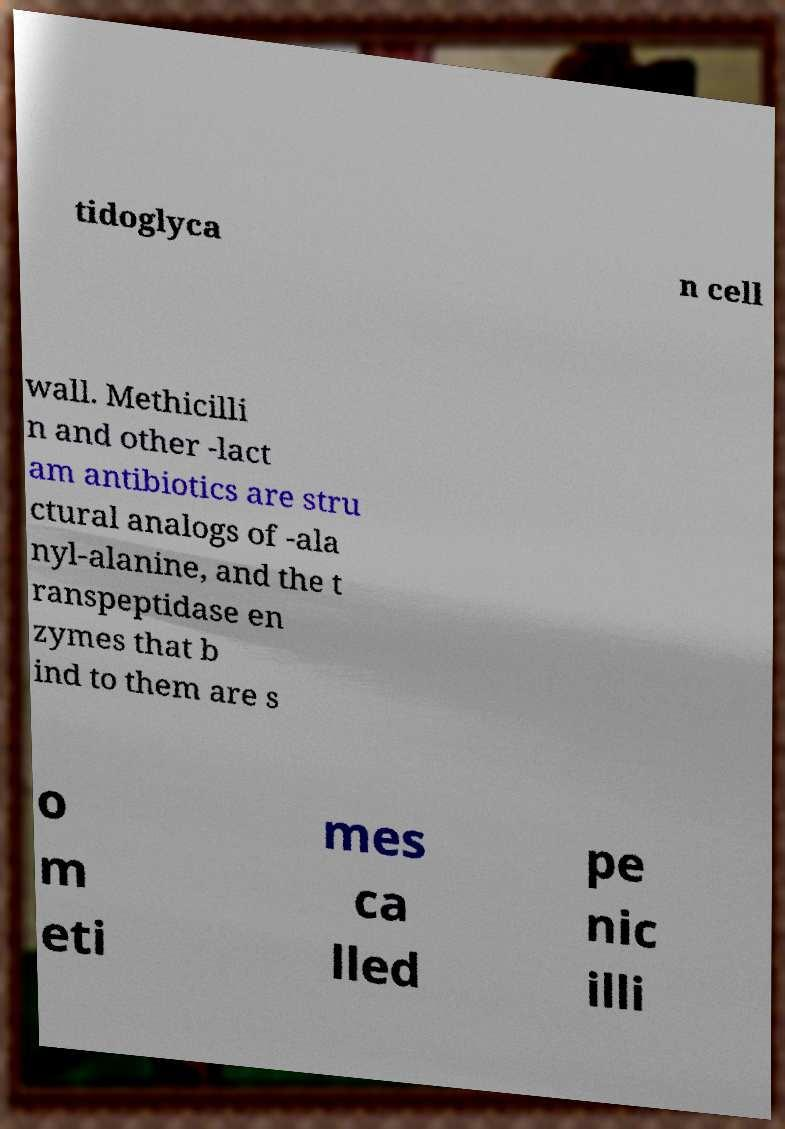What messages or text are displayed in this image? I need them in a readable, typed format. tidoglyca n cell wall. Methicilli n and other -lact am antibiotics are stru ctural analogs of -ala nyl-alanine, and the t ranspeptidase en zymes that b ind to them are s o m eti mes ca lled pe nic illi 